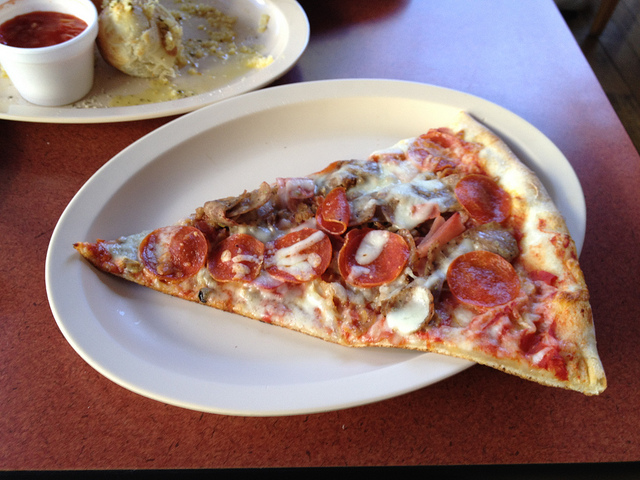Can you describe the main features of this image for me?
In the manner of an art connoisseur. The image presents a delightful scene of a pizza slice, served on a white plate. The pizza slice, with its triangular shape, dominates the plate with its vibrant colors and variety of toppings. 

The crust of the pizza is a golden brown, baked to perfection. The toppings are a mix of red, white, and brown colors, indicating a variety of ingredients. There are round slices of pepperoni that add a rich red color to the pizza. Sausage pieces, brown and savory, are scattered across the slice. White onions, chopped and spread evenly, add a bit of crunch and sharpness. Lastly, there are mushrooms that bring an earthy brown color and a unique texture to the mix.

The plate holding this mouth-watering slice is placed on a wooden table, adding a rustic touch to the scene. In the background, there's a small dish filled with red sauce, possibly for dipping the crust or adding extra flavor to the pizza slice.

Overall, this image captures a simple yet satisfying meal - a slice of pizza with diverse toppings, ready to be enjoyed. 